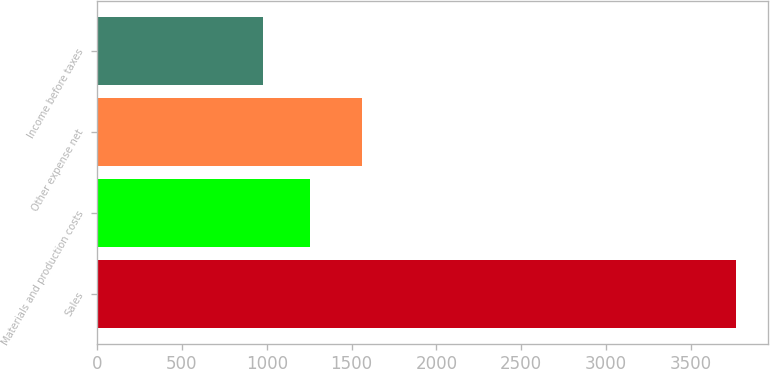Convert chart to OTSL. <chart><loc_0><loc_0><loc_500><loc_500><bar_chart><fcel>Sales<fcel>Materials and production costs<fcel>Other expense net<fcel>Income before taxes<nl><fcel>3767<fcel>1256.54<fcel>1564.1<fcel>977.6<nl></chart> 